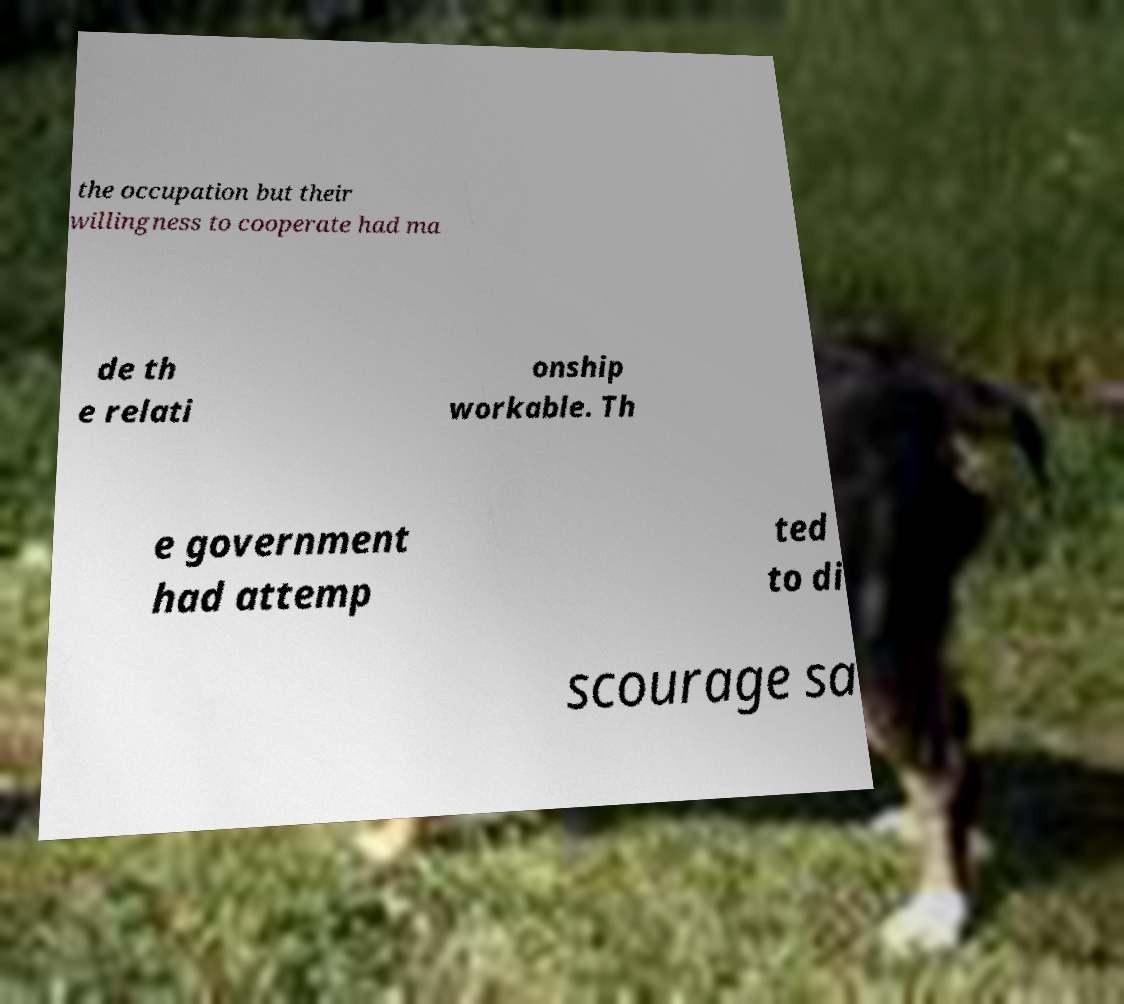Can you read and provide the text displayed in the image?This photo seems to have some interesting text. Can you extract and type it out for me? the occupation but their willingness to cooperate had ma de th e relati onship workable. Th e government had attemp ted to di scourage sa 